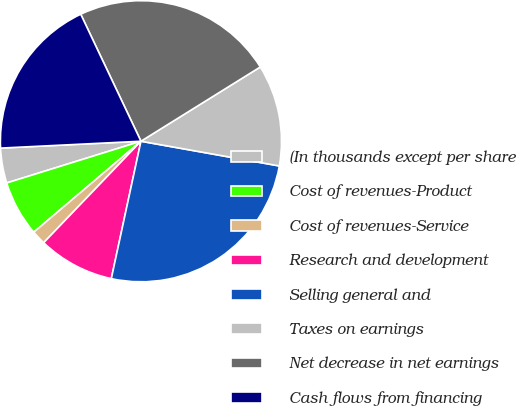<chart> <loc_0><loc_0><loc_500><loc_500><pie_chart><fcel>(In thousands except per share<fcel>Cost of revenues-Product<fcel>Cost of revenues-Service<fcel>Research and development<fcel>Selling general and<fcel>Taxes on earnings<fcel>Net decrease in net earnings<fcel>Cash flows from financing<nl><fcel>4.02%<fcel>6.4%<fcel>1.64%<fcel>8.78%<fcel>25.57%<fcel>11.67%<fcel>23.19%<fcel>18.73%<nl></chart> 